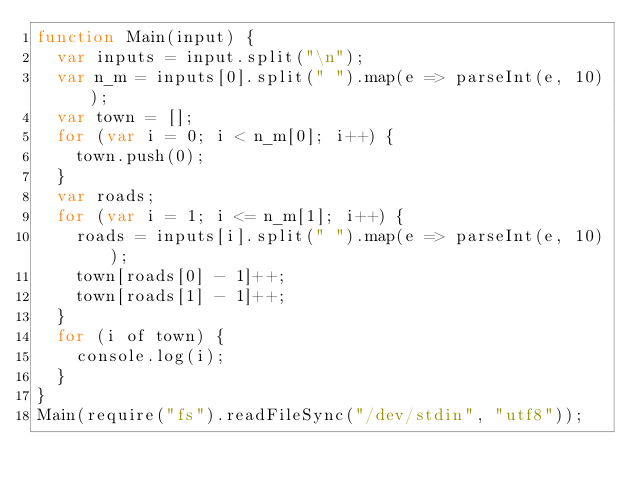Convert code to text. <code><loc_0><loc_0><loc_500><loc_500><_JavaScript_>function Main(input) {
  var inputs = input.split("\n");
  var n_m = inputs[0].split(" ").map(e => parseInt(e, 10));
  var town = [];
  for (var i = 0; i < n_m[0]; i++) {
    town.push(0);
  }
  var roads;
  for (var i = 1; i <= n_m[1]; i++) {
    roads = inputs[i].split(" ").map(e => parseInt(e, 10));
    town[roads[0] - 1]++;
    town[roads[1] - 1]++;
  }
  for (i of town) {
    console.log(i);
  }
}
Main(require("fs").readFileSync("/dev/stdin", "utf8"));</code> 